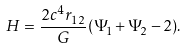<formula> <loc_0><loc_0><loc_500><loc_500>H = \frac { 2 c ^ { 4 } r _ { 1 2 } } { G } ( \Psi _ { 1 } + \Psi _ { 2 } - 2 ) .</formula> 